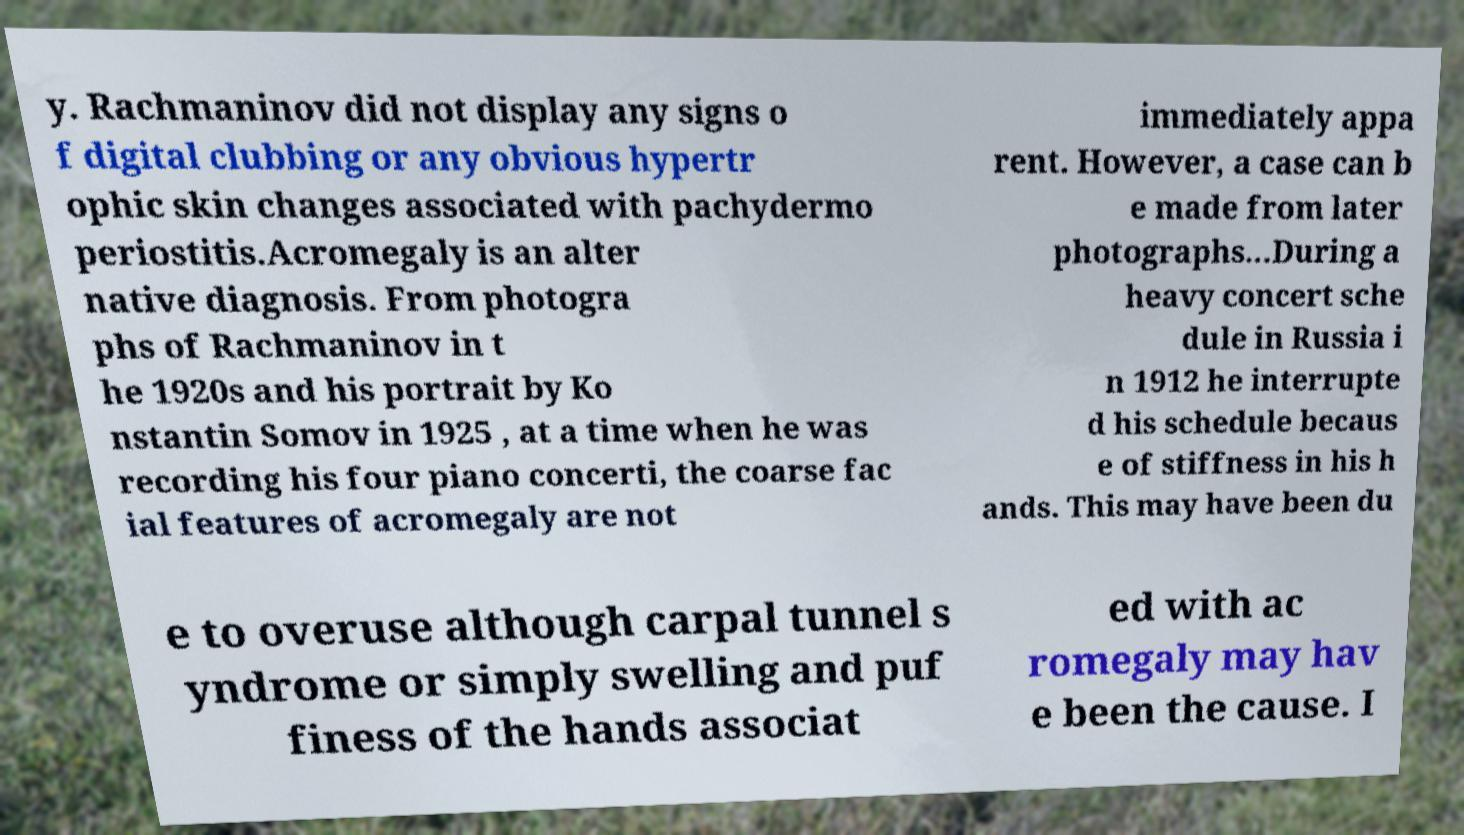I need the written content from this picture converted into text. Can you do that? y. Rachmaninov did not display any signs o f digital clubbing or any obvious hypertr ophic skin changes associated with pachydermo periostitis.Acromegaly is an alter native diagnosis. From photogra phs of Rachmaninov in t he 1920s and his portrait by Ko nstantin Somov in 1925 , at a time when he was recording his four piano concerti, the coarse fac ial features of acromegaly are not immediately appa rent. However, a case can b e made from later photographs...During a heavy concert sche dule in Russia i n 1912 he interrupte d his schedule becaus e of stiffness in his h ands. This may have been du e to overuse although carpal tunnel s yndrome or simply swelling and puf finess of the hands associat ed with ac romegaly may hav e been the cause. I 